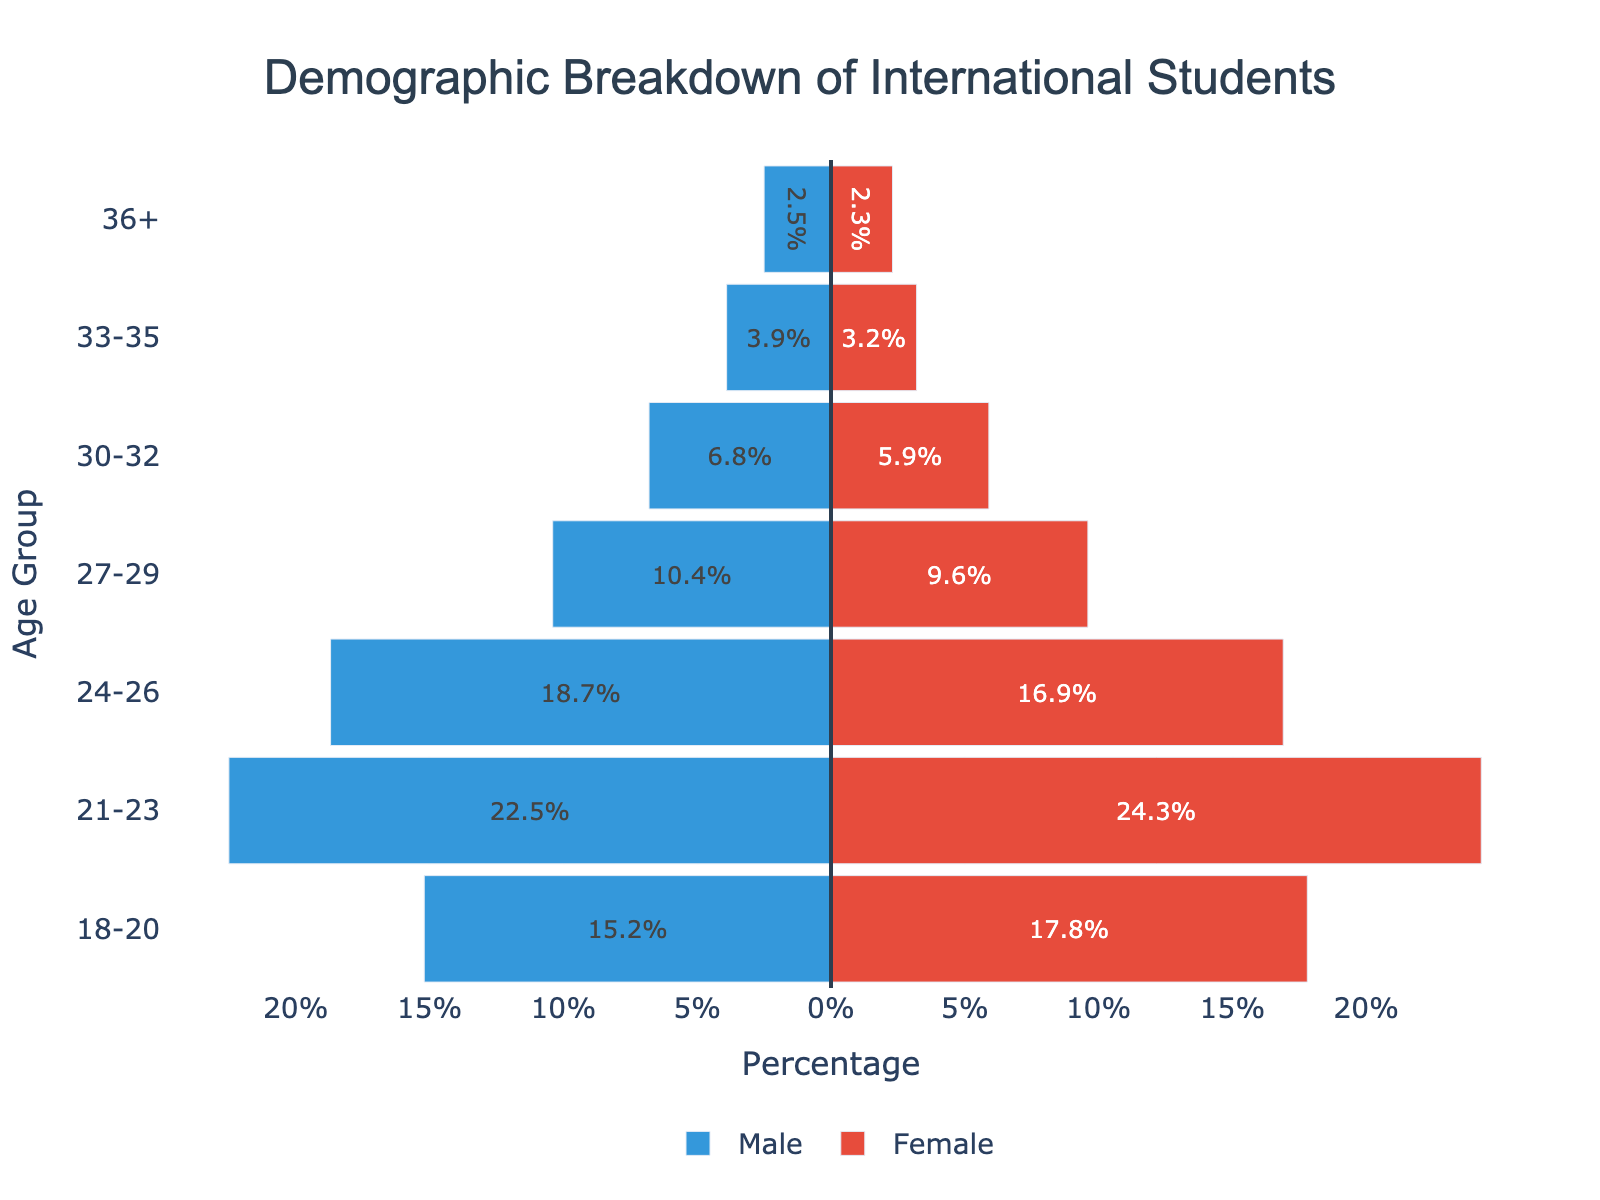What is the title of the figure? The title can be found at the top of the figure, giving an overall idea of what the graph represents.
Answer: Demographic Breakdown of International Students What are the colors used to represent male and female students? By looking at the bars, you can see that the male bars are colored in blue and the female bars in red.
Answer: Blue for male, red for female Which age group has the highest percentage of male students? Look for the longest bar on the left side of the zero line; this represents the highest percentage of male students. It corresponds to the 21-23 age group.
Answer: 21-23 What is the percentage of female students in the 30-32 age group? Check the bar corresponding to the 30-32 age group on the right side of the zero line. The length of this bar indicates the percentage.
Answer: 5.9% What is the difference in percentage between male and female students in the 18-20 age group? Find the lengths of both the male and female bars in the 18-20 age group and subtract the smaller percentage from the larger one (17.8 - 15.2).
Answer: 2.6% Compare the number of students aged 27-29 with those aged 33-35. Which has a higher combined percentage? Sum the percentages for males and females in each age group, then compare (27-29: 10.4 + 9.6 = 20.0, 33-35: 3.9 + 3.2 = 7.1).
Answer: 27-29 What is the total percentage of female students across all age groups? Add the percentages of female students in all age groups (17.8 + 24.3 + 16.9 + 9.6 + 5.9 + 3.2 + 2.3).
Answer: 80% Which age group has the lowest percentage of male students? Locate the shortest bar on the left side of the zero line; this represents the lowest percentage of male students. It corresponds to the 36+ age group.
Answer: 36+ 